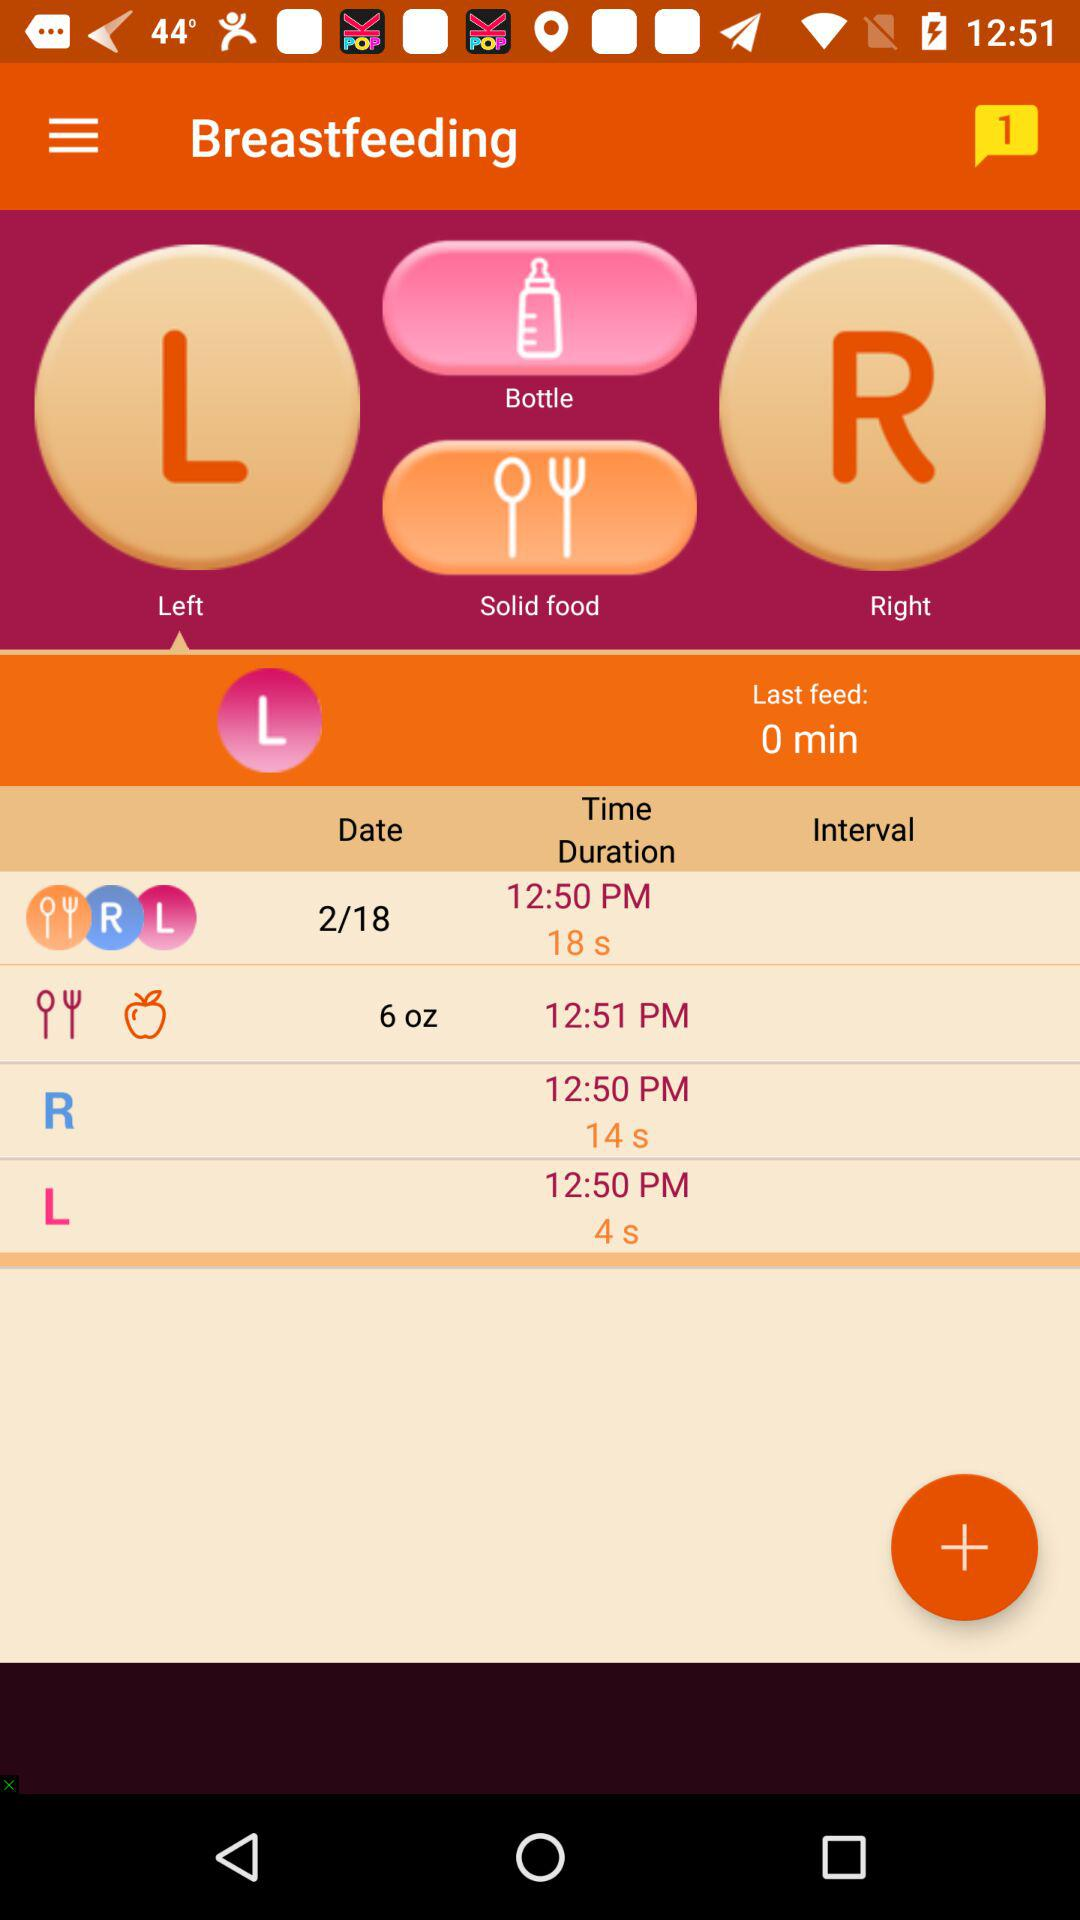What is the version number of the application?
When the provided information is insufficient, respond with <no answer>. <no answer> 